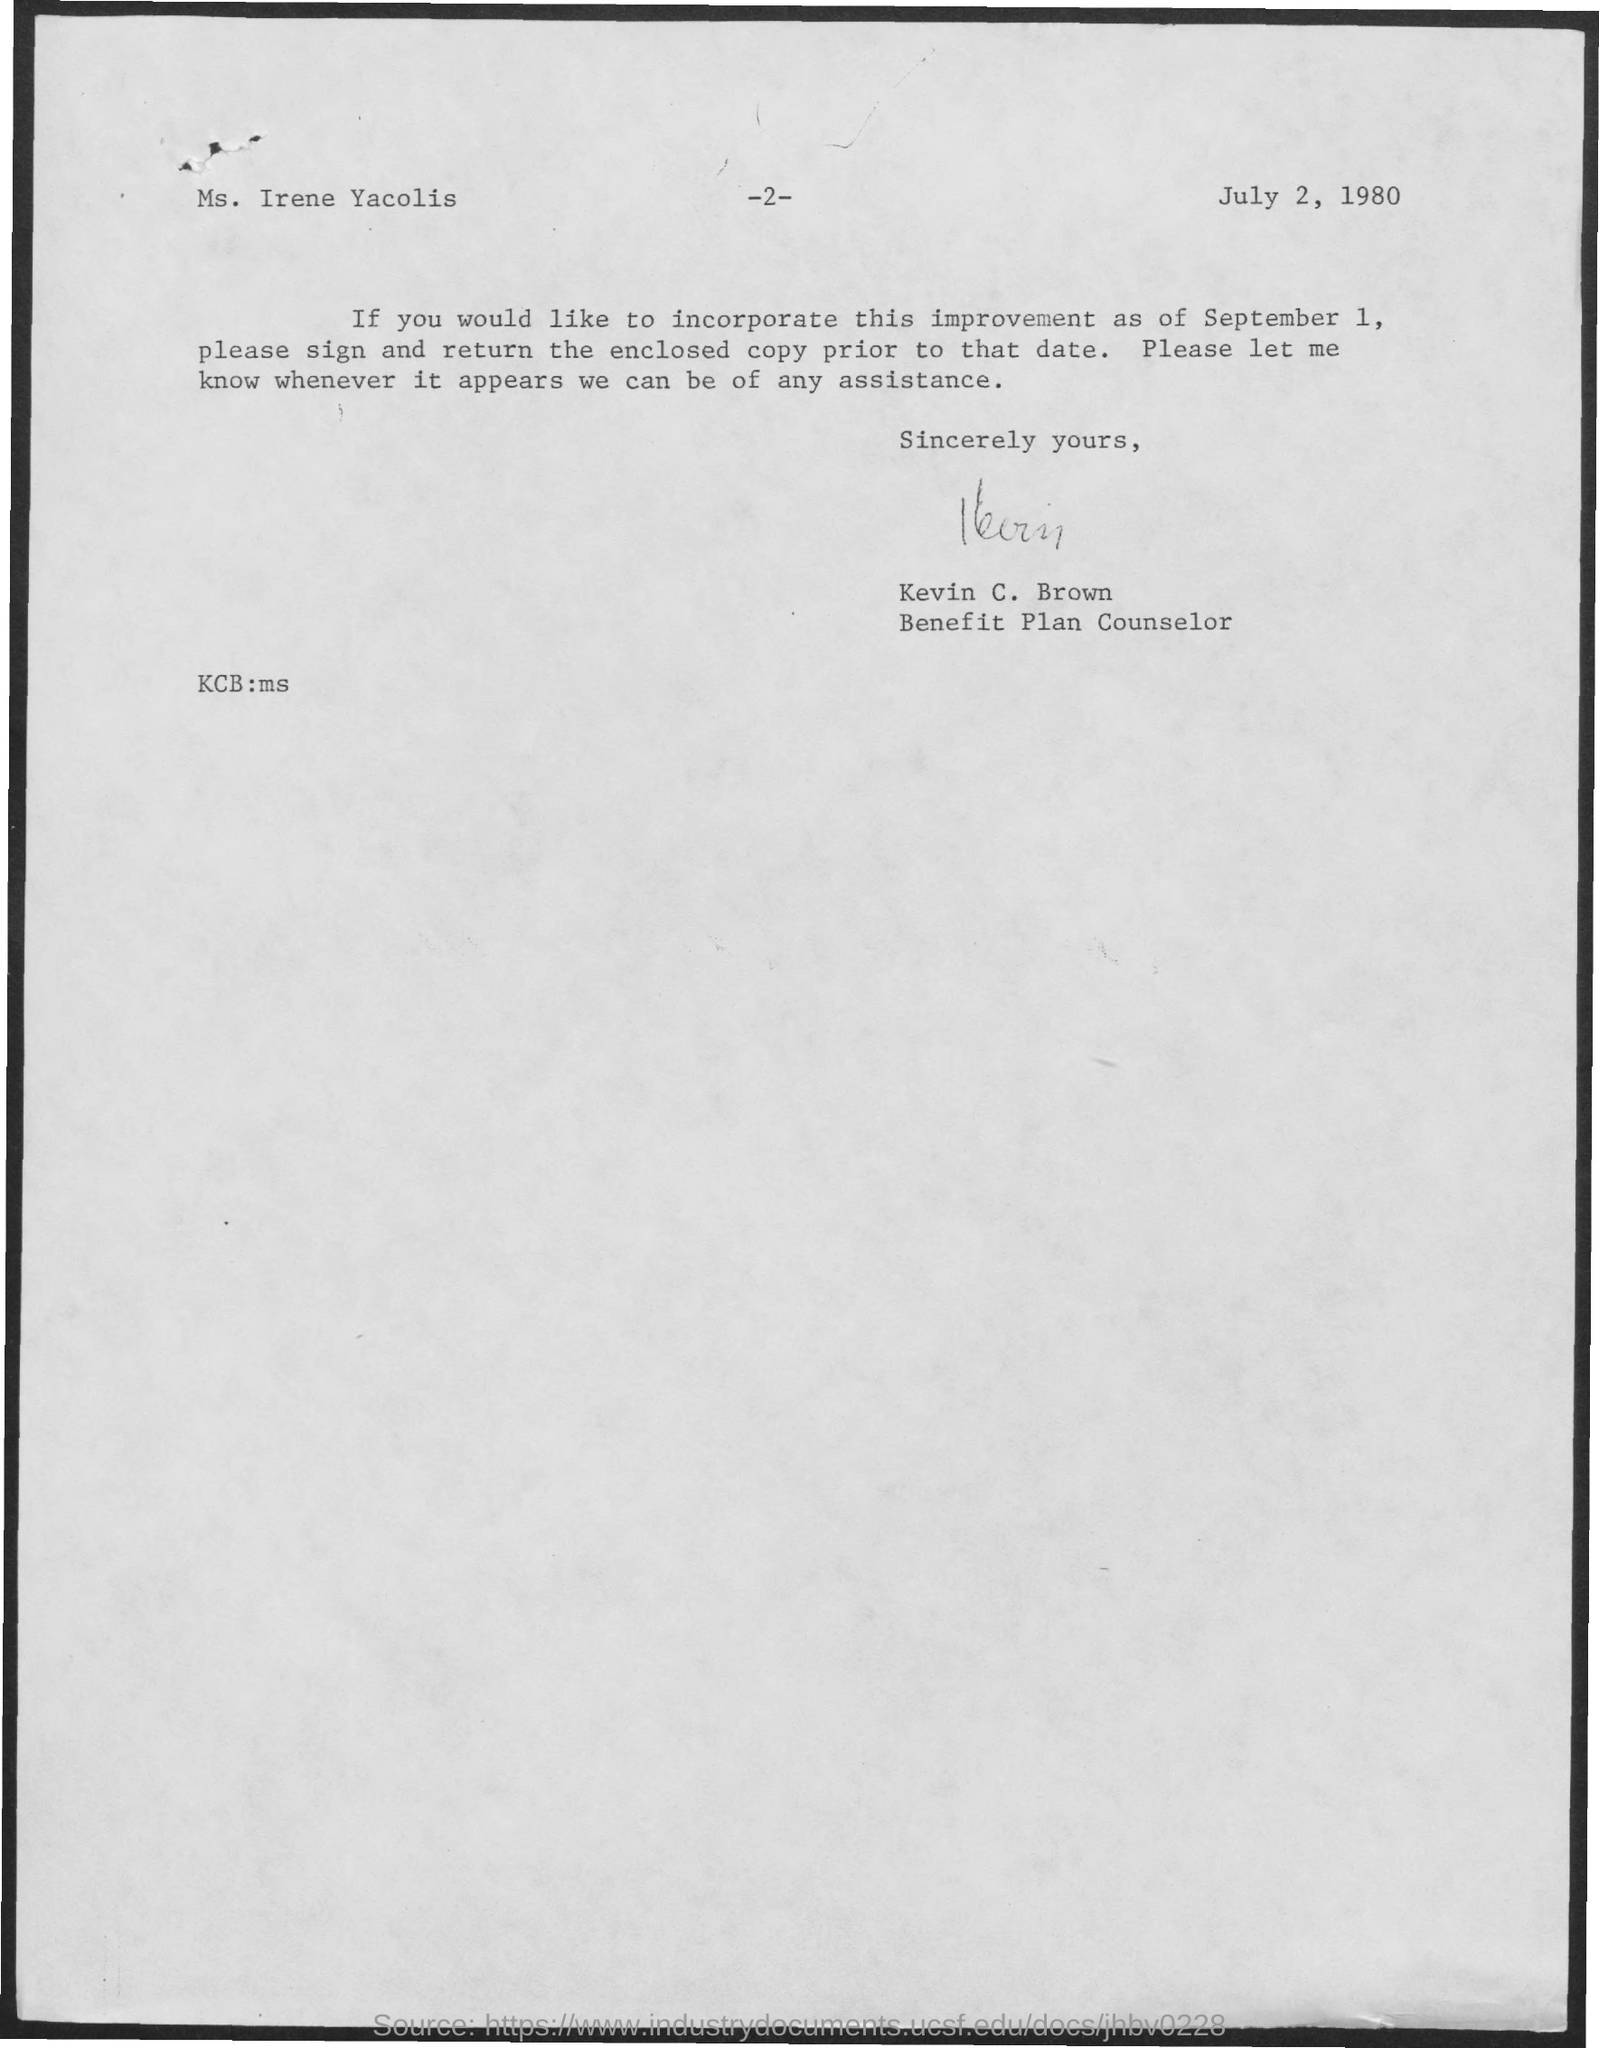What is the date on the document?
Give a very brief answer. July 2, 1980. To Whom is this letter addressed to?
Give a very brief answer. MS. IRENE YACOLIS. Who is this letter from?
Your answer should be compact. KEVIN C. BROWN. What is the Page Number?
Give a very brief answer. 2. 